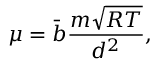<formula> <loc_0><loc_0><loc_500><loc_500>\mu = \bar { b } \frac { m \sqrt { R T } } { d ^ { 2 } } ,</formula> 